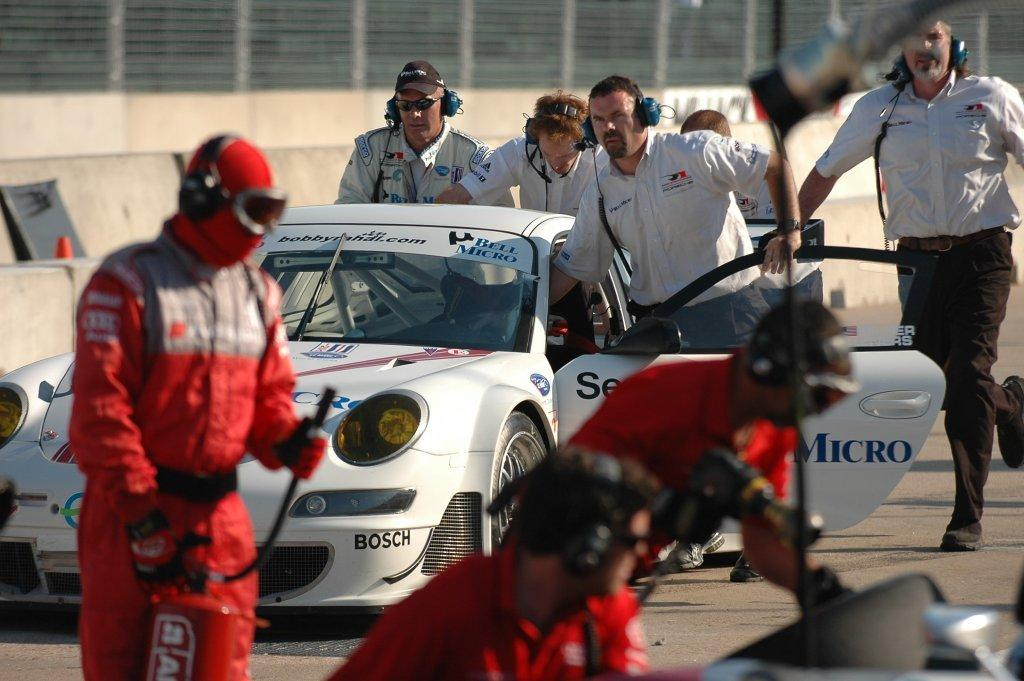Who or what is present in the image? There are people in the image. What are the people wearing? The people are wearing white and red color dress. What are the people holding in their hands? The people are holding something. Can you describe any other objects in the image? There is a white color car in the image. What type of bone can be seen in the image? There is no bone present in the image. Can you tell me how many bikes are visible in the image? There are no bikes visible in the image. 